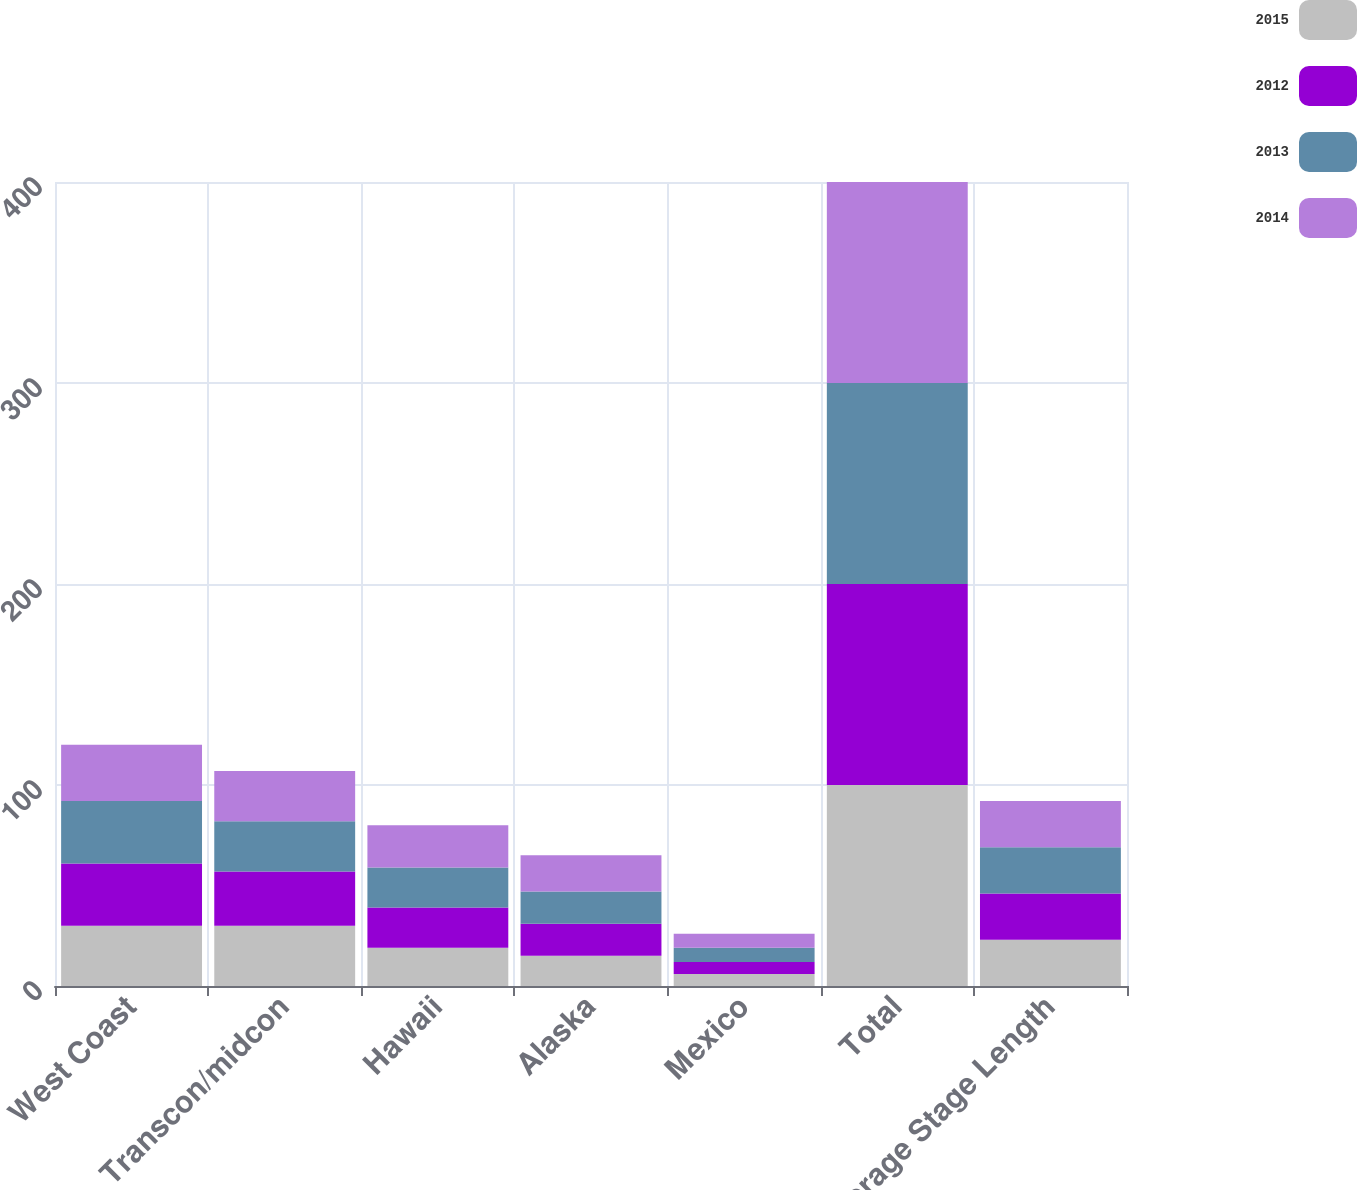<chart> <loc_0><loc_0><loc_500><loc_500><stacked_bar_chart><ecel><fcel>West Coast<fcel>Transcon/midcon<fcel>Hawaii<fcel>Alaska<fcel>Mexico<fcel>Total<fcel>Average Stage Length<nl><fcel>2015<fcel>30<fcel>30<fcel>19<fcel>15<fcel>6<fcel>100<fcel>23<nl><fcel>2012<fcel>31<fcel>27<fcel>20<fcel>16<fcel>6<fcel>100<fcel>23<nl><fcel>2013<fcel>31<fcel>25<fcel>20<fcel>16<fcel>7<fcel>100<fcel>23<nl><fcel>2014<fcel>28<fcel>25<fcel>21<fcel>18<fcel>7<fcel>100<fcel>23<nl></chart> 